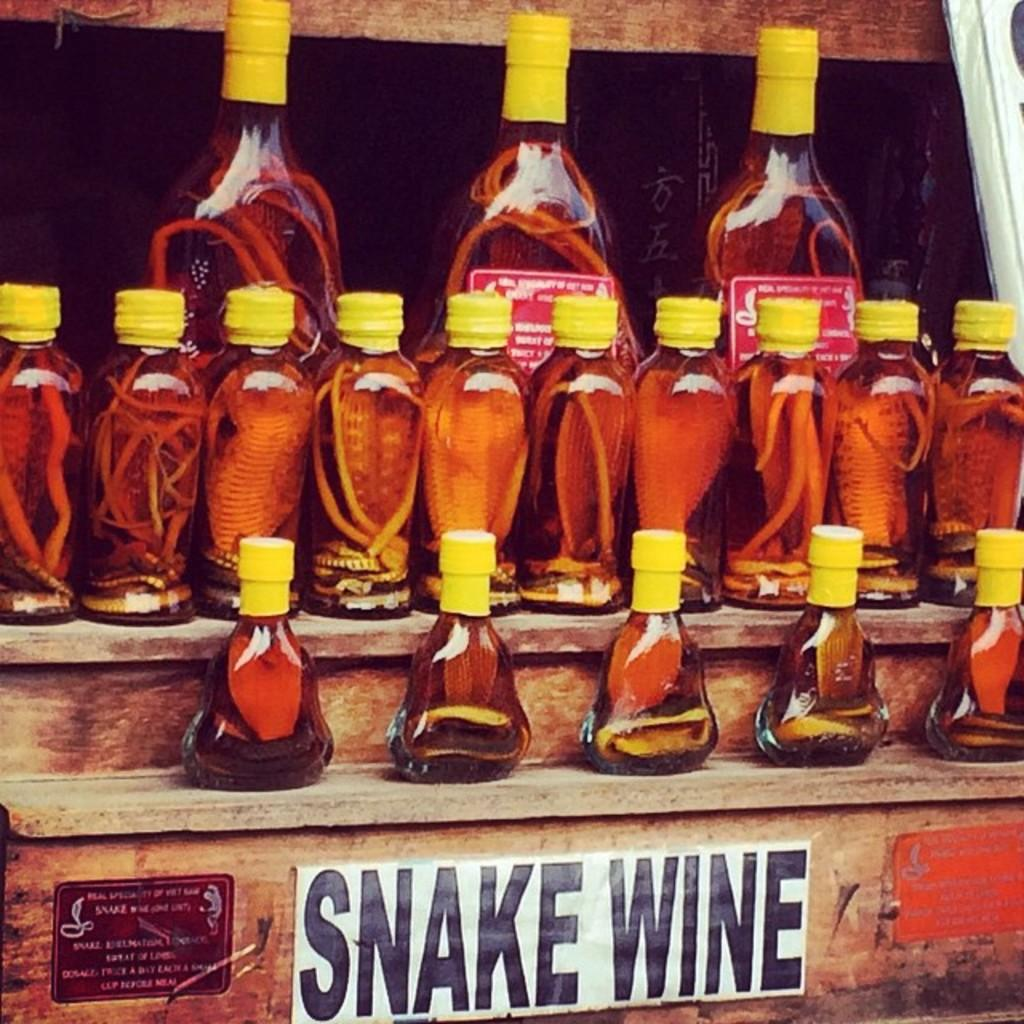<image>
Summarize the visual content of the image. Multiple bottles of Snake Wine are arranged on various wooden shelves. 